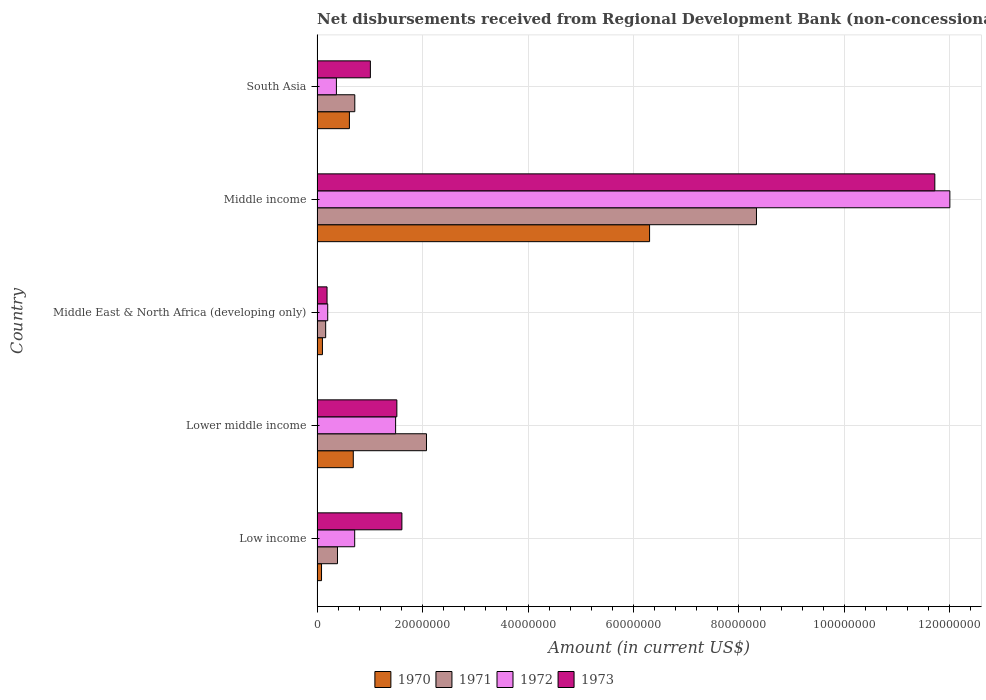How many groups of bars are there?
Ensure brevity in your answer.  5. Are the number of bars per tick equal to the number of legend labels?
Give a very brief answer. Yes. Are the number of bars on each tick of the Y-axis equal?
Make the answer very short. Yes. What is the label of the 4th group of bars from the top?
Offer a very short reply. Lower middle income. What is the amount of disbursements received from Regional Development Bank in 1971 in Middle income?
Your answer should be very brief. 8.33e+07. Across all countries, what is the maximum amount of disbursements received from Regional Development Bank in 1972?
Give a very brief answer. 1.20e+08. Across all countries, what is the minimum amount of disbursements received from Regional Development Bank in 1971?
Provide a short and direct response. 1.64e+06. In which country was the amount of disbursements received from Regional Development Bank in 1971 maximum?
Offer a terse response. Middle income. In which country was the amount of disbursements received from Regional Development Bank in 1971 minimum?
Your answer should be very brief. Middle East & North Africa (developing only). What is the total amount of disbursements received from Regional Development Bank in 1973 in the graph?
Ensure brevity in your answer.  1.60e+08. What is the difference between the amount of disbursements received from Regional Development Bank in 1970 in Middle East & North Africa (developing only) and that in South Asia?
Provide a succinct answer. -5.11e+06. What is the difference between the amount of disbursements received from Regional Development Bank in 1971 in Lower middle income and the amount of disbursements received from Regional Development Bank in 1973 in Middle East & North Africa (developing only)?
Provide a succinct answer. 1.89e+07. What is the average amount of disbursements received from Regional Development Bank in 1971 per country?
Your response must be concise. 2.33e+07. What is the difference between the amount of disbursements received from Regional Development Bank in 1970 and amount of disbursements received from Regional Development Bank in 1972 in Middle income?
Offer a terse response. -5.69e+07. In how many countries, is the amount of disbursements received from Regional Development Bank in 1971 greater than 48000000 US$?
Your answer should be very brief. 1. What is the ratio of the amount of disbursements received from Regional Development Bank in 1970 in Lower middle income to that in South Asia?
Your response must be concise. 1.12. Is the amount of disbursements received from Regional Development Bank in 1971 in Middle East & North Africa (developing only) less than that in Middle income?
Ensure brevity in your answer.  Yes. Is the difference between the amount of disbursements received from Regional Development Bank in 1970 in Middle East & North Africa (developing only) and South Asia greater than the difference between the amount of disbursements received from Regional Development Bank in 1972 in Middle East & North Africa (developing only) and South Asia?
Keep it short and to the point. No. What is the difference between the highest and the second highest amount of disbursements received from Regional Development Bank in 1972?
Offer a very short reply. 1.05e+08. What is the difference between the highest and the lowest amount of disbursements received from Regional Development Bank in 1973?
Your answer should be very brief. 1.15e+08. In how many countries, is the amount of disbursements received from Regional Development Bank in 1973 greater than the average amount of disbursements received from Regional Development Bank in 1973 taken over all countries?
Your response must be concise. 1. Is it the case that in every country, the sum of the amount of disbursements received from Regional Development Bank in 1973 and amount of disbursements received from Regional Development Bank in 1972 is greater than the sum of amount of disbursements received from Regional Development Bank in 1971 and amount of disbursements received from Regional Development Bank in 1970?
Keep it short and to the point. No. What does the 3rd bar from the top in Lower middle income represents?
Provide a succinct answer. 1971. How many bars are there?
Provide a succinct answer. 20. Are all the bars in the graph horizontal?
Offer a terse response. Yes. Does the graph contain any zero values?
Ensure brevity in your answer.  No. Does the graph contain grids?
Your answer should be compact. Yes. Where does the legend appear in the graph?
Give a very brief answer. Bottom center. What is the title of the graph?
Offer a terse response. Net disbursements received from Regional Development Bank (non-concessional). Does "1983" appear as one of the legend labels in the graph?
Keep it short and to the point. No. What is the label or title of the X-axis?
Your answer should be compact. Amount (in current US$). What is the label or title of the Y-axis?
Keep it short and to the point. Country. What is the Amount (in current US$) of 1970 in Low income?
Offer a terse response. 8.50e+05. What is the Amount (in current US$) in 1971 in Low income?
Your response must be concise. 3.88e+06. What is the Amount (in current US$) in 1972 in Low income?
Your answer should be compact. 7.14e+06. What is the Amount (in current US$) of 1973 in Low income?
Offer a very short reply. 1.61e+07. What is the Amount (in current US$) in 1970 in Lower middle income?
Your answer should be compact. 6.87e+06. What is the Amount (in current US$) in 1971 in Lower middle income?
Keep it short and to the point. 2.08e+07. What is the Amount (in current US$) in 1972 in Lower middle income?
Provide a succinct answer. 1.49e+07. What is the Amount (in current US$) of 1973 in Lower middle income?
Give a very brief answer. 1.51e+07. What is the Amount (in current US$) in 1970 in Middle East & North Africa (developing only)?
Give a very brief answer. 1.02e+06. What is the Amount (in current US$) of 1971 in Middle East & North Africa (developing only)?
Your answer should be very brief. 1.64e+06. What is the Amount (in current US$) of 1972 in Middle East & North Africa (developing only)?
Ensure brevity in your answer.  2.02e+06. What is the Amount (in current US$) in 1973 in Middle East & North Africa (developing only)?
Give a very brief answer. 1.90e+06. What is the Amount (in current US$) of 1970 in Middle income?
Your response must be concise. 6.31e+07. What is the Amount (in current US$) of 1971 in Middle income?
Offer a very short reply. 8.33e+07. What is the Amount (in current US$) of 1972 in Middle income?
Make the answer very short. 1.20e+08. What is the Amount (in current US$) of 1973 in Middle income?
Your answer should be compact. 1.17e+08. What is the Amount (in current US$) in 1970 in South Asia?
Ensure brevity in your answer.  6.13e+06. What is the Amount (in current US$) in 1971 in South Asia?
Your answer should be very brief. 7.16e+06. What is the Amount (in current US$) of 1972 in South Asia?
Provide a short and direct response. 3.67e+06. What is the Amount (in current US$) of 1973 in South Asia?
Your response must be concise. 1.01e+07. Across all countries, what is the maximum Amount (in current US$) in 1970?
Keep it short and to the point. 6.31e+07. Across all countries, what is the maximum Amount (in current US$) in 1971?
Provide a succinct answer. 8.33e+07. Across all countries, what is the maximum Amount (in current US$) of 1972?
Your response must be concise. 1.20e+08. Across all countries, what is the maximum Amount (in current US$) in 1973?
Make the answer very short. 1.17e+08. Across all countries, what is the minimum Amount (in current US$) of 1970?
Provide a short and direct response. 8.50e+05. Across all countries, what is the minimum Amount (in current US$) of 1971?
Offer a terse response. 1.64e+06. Across all countries, what is the minimum Amount (in current US$) of 1972?
Provide a short and direct response. 2.02e+06. Across all countries, what is the minimum Amount (in current US$) in 1973?
Your answer should be compact. 1.90e+06. What is the total Amount (in current US$) in 1970 in the graph?
Your answer should be compact. 7.79e+07. What is the total Amount (in current US$) of 1971 in the graph?
Give a very brief answer. 1.17e+08. What is the total Amount (in current US$) in 1972 in the graph?
Offer a very short reply. 1.48e+08. What is the total Amount (in current US$) in 1973 in the graph?
Ensure brevity in your answer.  1.60e+08. What is the difference between the Amount (in current US$) of 1970 in Low income and that in Lower middle income?
Ensure brevity in your answer.  -6.02e+06. What is the difference between the Amount (in current US$) of 1971 in Low income and that in Lower middle income?
Your answer should be compact. -1.69e+07. What is the difference between the Amount (in current US$) in 1972 in Low income and that in Lower middle income?
Give a very brief answer. -7.76e+06. What is the difference between the Amount (in current US$) of 1973 in Low income and that in Lower middle income?
Give a very brief answer. 9.55e+05. What is the difference between the Amount (in current US$) in 1970 in Low income and that in Middle East & North Africa (developing only)?
Provide a short and direct response. -1.71e+05. What is the difference between the Amount (in current US$) of 1971 in Low income and that in Middle East & North Africa (developing only)?
Make the answer very short. 2.24e+06. What is the difference between the Amount (in current US$) in 1972 in Low income and that in Middle East & North Africa (developing only)?
Provide a short and direct response. 5.11e+06. What is the difference between the Amount (in current US$) in 1973 in Low income and that in Middle East & North Africa (developing only)?
Offer a very short reply. 1.42e+07. What is the difference between the Amount (in current US$) in 1970 in Low income and that in Middle income?
Make the answer very short. -6.22e+07. What is the difference between the Amount (in current US$) of 1971 in Low income and that in Middle income?
Offer a terse response. -7.94e+07. What is the difference between the Amount (in current US$) of 1972 in Low income and that in Middle income?
Keep it short and to the point. -1.13e+08. What is the difference between the Amount (in current US$) in 1973 in Low income and that in Middle income?
Offer a terse response. -1.01e+08. What is the difference between the Amount (in current US$) in 1970 in Low income and that in South Asia?
Provide a short and direct response. -5.28e+06. What is the difference between the Amount (in current US$) in 1971 in Low income and that in South Asia?
Your answer should be very brief. -3.28e+06. What is the difference between the Amount (in current US$) of 1972 in Low income and that in South Asia?
Make the answer very short. 3.47e+06. What is the difference between the Amount (in current US$) in 1973 in Low income and that in South Asia?
Make the answer very short. 5.98e+06. What is the difference between the Amount (in current US$) in 1970 in Lower middle income and that in Middle East & North Africa (developing only)?
Give a very brief answer. 5.85e+06. What is the difference between the Amount (in current US$) of 1971 in Lower middle income and that in Middle East & North Africa (developing only)?
Provide a succinct answer. 1.91e+07. What is the difference between the Amount (in current US$) in 1972 in Lower middle income and that in Middle East & North Africa (developing only)?
Offer a terse response. 1.29e+07. What is the difference between the Amount (in current US$) of 1973 in Lower middle income and that in Middle East & North Africa (developing only)?
Your response must be concise. 1.32e+07. What is the difference between the Amount (in current US$) of 1970 in Lower middle income and that in Middle income?
Make the answer very short. -5.62e+07. What is the difference between the Amount (in current US$) of 1971 in Lower middle income and that in Middle income?
Keep it short and to the point. -6.26e+07. What is the difference between the Amount (in current US$) in 1972 in Lower middle income and that in Middle income?
Ensure brevity in your answer.  -1.05e+08. What is the difference between the Amount (in current US$) of 1973 in Lower middle income and that in Middle income?
Offer a terse response. -1.02e+08. What is the difference between the Amount (in current US$) of 1970 in Lower middle income and that in South Asia?
Keep it short and to the point. 7.37e+05. What is the difference between the Amount (in current US$) of 1971 in Lower middle income and that in South Asia?
Offer a terse response. 1.36e+07. What is the difference between the Amount (in current US$) in 1972 in Lower middle income and that in South Asia?
Offer a terse response. 1.12e+07. What is the difference between the Amount (in current US$) of 1973 in Lower middle income and that in South Asia?
Offer a very short reply. 5.02e+06. What is the difference between the Amount (in current US$) of 1970 in Middle East & North Africa (developing only) and that in Middle income?
Your answer should be compact. -6.20e+07. What is the difference between the Amount (in current US$) of 1971 in Middle East & North Africa (developing only) and that in Middle income?
Keep it short and to the point. -8.17e+07. What is the difference between the Amount (in current US$) in 1972 in Middle East & North Africa (developing only) and that in Middle income?
Your answer should be very brief. -1.18e+08. What is the difference between the Amount (in current US$) in 1973 in Middle East & North Africa (developing only) and that in Middle income?
Your answer should be compact. -1.15e+08. What is the difference between the Amount (in current US$) of 1970 in Middle East & North Africa (developing only) and that in South Asia?
Keep it short and to the point. -5.11e+06. What is the difference between the Amount (in current US$) in 1971 in Middle East & North Africa (developing only) and that in South Asia?
Offer a very short reply. -5.52e+06. What is the difference between the Amount (in current US$) of 1972 in Middle East & North Africa (developing only) and that in South Asia?
Give a very brief answer. -1.64e+06. What is the difference between the Amount (in current US$) of 1973 in Middle East & North Africa (developing only) and that in South Asia?
Make the answer very short. -8.22e+06. What is the difference between the Amount (in current US$) in 1970 in Middle income and that in South Asia?
Keep it short and to the point. 5.69e+07. What is the difference between the Amount (in current US$) of 1971 in Middle income and that in South Asia?
Provide a short and direct response. 7.62e+07. What is the difference between the Amount (in current US$) of 1972 in Middle income and that in South Asia?
Offer a very short reply. 1.16e+08. What is the difference between the Amount (in current US$) of 1973 in Middle income and that in South Asia?
Provide a short and direct response. 1.07e+08. What is the difference between the Amount (in current US$) in 1970 in Low income and the Amount (in current US$) in 1971 in Lower middle income?
Your answer should be compact. -1.99e+07. What is the difference between the Amount (in current US$) of 1970 in Low income and the Amount (in current US$) of 1972 in Lower middle income?
Offer a terse response. -1.40e+07. What is the difference between the Amount (in current US$) of 1970 in Low income and the Amount (in current US$) of 1973 in Lower middle income?
Make the answer very short. -1.43e+07. What is the difference between the Amount (in current US$) in 1971 in Low income and the Amount (in current US$) in 1972 in Lower middle income?
Make the answer very short. -1.10e+07. What is the difference between the Amount (in current US$) of 1971 in Low income and the Amount (in current US$) of 1973 in Lower middle income?
Offer a terse response. -1.13e+07. What is the difference between the Amount (in current US$) in 1972 in Low income and the Amount (in current US$) in 1973 in Lower middle income?
Offer a terse response. -8.00e+06. What is the difference between the Amount (in current US$) in 1970 in Low income and the Amount (in current US$) in 1971 in Middle East & North Africa (developing only)?
Your answer should be very brief. -7.85e+05. What is the difference between the Amount (in current US$) in 1970 in Low income and the Amount (in current US$) in 1972 in Middle East & North Africa (developing only)?
Provide a short and direct response. -1.17e+06. What is the difference between the Amount (in current US$) of 1970 in Low income and the Amount (in current US$) of 1973 in Middle East & North Africa (developing only)?
Your answer should be compact. -1.05e+06. What is the difference between the Amount (in current US$) in 1971 in Low income and the Amount (in current US$) in 1972 in Middle East & North Africa (developing only)?
Offer a very short reply. 1.85e+06. What is the difference between the Amount (in current US$) of 1971 in Low income and the Amount (in current US$) of 1973 in Middle East & North Africa (developing only)?
Make the answer very short. 1.98e+06. What is the difference between the Amount (in current US$) of 1972 in Low income and the Amount (in current US$) of 1973 in Middle East & North Africa (developing only)?
Offer a very short reply. 5.24e+06. What is the difference between the Amount (in current US$) in 1970 in Low income and the Amount (in current US$) in 1971 in Middle income?
Give a very brief answer. -8.25e+07. What is the difference between the Amount (in current US$) of 1970 in Low income and the Amount (in current US$) of 1972 in Middle income?
Give a very brief answer. -1.19e+08. What is the difference between the Amount (in current US$) of 1970 in Low income and the Amount (in current US$) of 1973 in Middle income?
Offer a terse response. -1.16e+08. What is the difference between the Amount (in current US$) in 1971 in Low income and the Amount (in current US$) in 1972 in Middle income?
Give a very brief answer. -1.16e+08. What is the difference between the Amount (in current US$) in 1971 in Low income and the Amount (in current US$) in 1973 in Middle income?
Keep it short and to the point. -1.13e+08. What is the difference between the Amount (in current US$) of 1972 in Low income and the Amount (in current US$) of 1973 in Middle income?
Provide a short and direct response. -1.10e+08. What is the difference between the Amount (in current US$) in 1970 in Low income and the Amount (in current US$) in 1971 in South Asia?
Your response must be concise. -6.31e+06. What is the difference between the Amount (in current US$) of 1970 in Low income and the Amount (in current US$) of 1972 in South Asia?
Give a very brief answer. -2.82e+06. What is the difference between the Amount (in current US$) in 1970 in Low income and the Amount (in current US$) in 1973 in South Asia?
Offer a very short reply. -9.26e+06. What is the difference between the Amount (in current US$) of 1971 in Low income and the Amount (in current US$) of 1972 in South Asia?
Provide a short and direct response. 2.06e+05. What is the difference between the Amount (in current US$) in 1971 in Low income and the Amount (in current US$) in 1973 in South Asia?
Give a very brief answer. -6.24e+06. What is the difference between the Amount (in current US$) in 1972 in Low income and the Amount (in current US$) in 1973 in South Asia?
Keep it short and to the point. -2.98e+06. What is the difference between the Amount (in current US$) of 1970 in Lower middle income and the Amount (in current US$) of 1971 in Middle East & North Africa (developing only)?
Make the answer very short. 5.24e+06. What is the difference between the Amount (in current US$) in 1970 in Lower middle income and the Amount (in current US$) in 1972 in Middle East & North Africa (developing only)?
Offer a terse response. 4.85e+06. What is the difference between the Amount (in current US$) of 1970 in Lower middle income and the Amount (in current US$) of 1973 in Middle East & North Africa (developing only)?
Offer a terse response. 4.98e+06. What is the difference between the Amount (in current US$) of 1971 in Lower middle income and the Amount (in current US$) of 1972 in Middle East & North Africa (developing only)?
Provide a short and direct response. 1.87e+07. What is the difference between the Amount (in current US$) in 1971 in Lower middle income and the Amount (in current US$) in 1973 in Middle East & North Africa (developing only)?
Provide a short and direct response. 1.89e+07. What is the difference between the Amount (in current US$) of 1972 in Lower middle income and the Amount (in current US$) of 1973 in Middle East & North Africa (developing only)?
Make the answer very short. 1.30e+07. What is the difference between the Amount (in current US$) of 1970 in Lower middle income and the Amount (in current US$) of 1971 in Middle income?
Your answer should be compact. -7.65e+07. What is the difference between the Amount (in current US$) in 1970 in Lower middle income and the Amount (in current US$) in 1972 in Middle income?
Offer a very short reply. -1.13e+08. What is the difference between the Amount (in current US$) of 1970 in Lower middle income and the Amount (in current US$) of 1973 in Middle income?
Offer a very short reply. -1.10e+08. What is the difference between the Amount (in current US$) in 1971 in Lower middle income and the Amount (in current US$) in 1972 in Middle income?
Provide a short and direct response. -9.92e+07. What is the difference between the Amount (in current US$) of 1971 in Lower middle income and the Amount (in current US$) of 1973 in Middle income?
Provide a short and direct response. -9.64e+07. What is the difference between the Amount (in current US$) in 1972 in Lower middle income and the Amount (in current US$) in 1973 in Middle income?
Provide a succinct answer. -1.02e+08. What is the difference between the Amount (in current US$) of 1970 in Lower middle income and the Amount (in current US$) of 1971 in South Asia?
Your answer should be compact. -2.87e+05. What is the difference between the Amount (in current US$) in 1970 in Lower middle income and the Amount (in current US$) in 1972 in South Asia?
Offer a terse response. 3.20e+06. What is the difference between the Amount (in current US$) of 1970 in Lower middle income and the Amount (in current US$) of 1973 in South Asia?
Make the answer very short. -3.24e+06. What is the difference between the Amount (in current US$) in 1971 in Lower middle income and the Amount (in current US$) in 1972 in South Asia?
Offer a terse response. 1.71e+07. What is the difference between the Amount (in current US$) of 1971 in Lower middle income and the Amount (in current US$) of 1973 in South Asia?
Keep it short and to the point. 1.06e+07. What is the difference between the Amount (in current US$) of 1972 in Lower middle income and the Amount (in current US$) of 1973 in South Asia?
Offer a very short reply. 4.78e+06. What is the difference between the Amount (in current US$) of 1970 in Middle East & North Africa (developing only) and the Amount (in current US$) of 1971 in Middle income?
Give a very brief answer. -8.23e+07. What is the difference between the Amount (in current US$) of 1970 in Middle East & North Africa (developing only) and the Amount (in current US$) of 1972 in Middle income?
Your answer should be very brief. -1.19e+08. What is the difference between the Amount (in current US$) of 1970 in Middle East & North Africa (developing only) and the Amount (in current US$) of 1973 in Middle income?
Give a very brief answer. -1.16e+08. What is the difference between the Amount (in current US$) of 1971 in Middle East & North Africa (developing only) and the Amount (in current US$) of 1972 in Middle income?
Offer a very short reply. -1.18e+08. What is the difference between the Amount (in current US$) of 1971 in Middle East & North Africa (developing only) and the Amount (in current US$) of 1973 in Middle income?
Keep it short and to the point. -1.16e+08. What is the difference between the Amount (in current US$) in 1972 in Middle East & North Africa (developing only) and the Amount (in current US$) in 1973 in Middle income?
Offer a terse response. -1.15e+08. What is the difference between the Amount (in current US$) of 1970 in Middle East & North Africa (developing only) and the Amount (in current US$) of 1971 in South Asia?
Ensure brevity in your answer.  -6.14e+06. What is the difference between the Amount (in current US$) of 1970 in Middle East & North Africa (developing only) and the Amount (in current US$) of 1972 in South Asia?
Make the answer very short. -2.65e+06. What is the difference between the Amount (in current US$) in 1970 in Middle East & North Africa (developing only) and the Amount (in current US$) in 1973 in South Asia?
Ensure brevity in your answer.  -9.09e+06. What is the difference between the Amount (in current US$) of 1971 in Middle East & North Africa (developing only) and the Amount (in current US$) of 1972 in South Asia?
Keep it short and to the point. -2.03e+06. What is the difference between the Amount (in current US$) of 1971 in Middle East & North Africa (developing only) and the Amount (in current US$) of 1973 in South Asia?
Your answer should be compact. -8.48e+06. What is the difference between the Amount (in current US$) in 1972 in Middle East & North Africa (developing only) and the Amount (in current US$) in 1973 in South Asia?
Keep it short and to the point. -8.09e+06. What is the difference between the Amount (in current US$) in 1970 in Middle income and the Amount (in current US$) in 1971 in South Asia?
Provide a short and direct response. 5.59e+07. What is the difference between the Amount (in current US$) of 1970 in Middle income and the Amount (in current US$) of 1972 in South Asia?
Provide a succinct answer. 5.94e+07. What is the difference between the Amount (in current US$) of 1970 in Middle income and the Amount (in current US$) of 1973 in South Asia?
Offer a very short reply. 5.29e+07. What is the difference between the Amount (in current US$) in 1971 in Middle income and the Amount (in current US$) in 1972 in South Asia?
Provide a short and direct response. 7.97e+07. What is the difference between the Amount (in current US$) in 1971 in Middle income and the Amount (in current US$) in 1973 in South Asia?
Offer a very short reply. 7.32e+07. What is the difference between the Amount (in current US$) in 1972 in Middle income and the Amount (in current US$) in 1973 in South Asia?
Provide a short and direct response. 1.10e+08. What is the average Amount (in current US$) in 1970 per country?
Ensure brevity in your answer.  1.56e+07. What is the average Amount (in current US$) of 1971 per country?
Your response must be concise. 2.33e+07. What is the average Amount (in current US$) of 1972 per country?
Offer a terse response. 2.95e+07. What is the average Amount (in current US$) in 1973 per country?
Ensure brevity in your answer.  3.21e+07. What is the difference between the Amount (in current US$) of 1970 and Amount (in current US$) of 1971 in Low income?
Provide a short and direct response. -3.02e+06. What is the difference between the Amount (in current US$) in 1970 and Amount (in current US$) in 1972 in Low income?
Give a very brief answer. -6.29e+06. What is the difference between the Amount (in current US$) of 1970 and Amount (in current US$) of 1973 in Low income?
Provide a succinct answer. -1.52e+07. What is the difference between the Amount (in current US$) of 1971 and Amount (in current US$) of 1972 in Low income?
Offer a very short reply. -3.26e+06. What is the difference between the Amount (in current US$) of 1971 and Amount (in current US$) of 1973 in Low income?
Ensure brevity in your answer.  -1.22e+07. What is the difference between the Amount (in current US$) in 1972 and Amount (in current US$) in 1973 in Low income?
Offer a terse response. -8.95e+06. What is the difference between the Amount (in current US$) in 1970 and Amount (in current US$) in 1971 in Lower middle income?
Provide a short and direct response. -1.39e+07. What is the difference between the Amount (in current US$) in 1970 and Amount (in current US$) in 1972 in Lower middle income?
Your answer should be compact. -8.03e+06. What is the difference between the Amount (in current US$) of 1970 and Amount (in current US$) of 1973 in Lower middle income?
Your response must be concise. -8.26e+06. What is the difference between the Amount (in current US$) of 1971 and Amount (in current US$) of 1972 in Lower middle income?
Offer a very short reply. 5.85e+06. What is the difference between the Amount (in current US$) of 1971 and Amount (in current US$) of 1973 in Lower middle income?
Keep it short and to the point. 5.62e+06. What is the difference between the Amount (in current US$) in 1972 and Amount (in current US$) in 1973 in Lower middle income?
Give a very brief answer. -2.36e+05. What is the difference between the Amount (in current US$) in 1970 and Amount (in current US$) in 1971 in Middle East & North Africa (developing only)?
Your response must be concise. -6.14e+05. What is the difference between the Amount (in current US$) in 1970 and Amount (in current US$) in 1972 in Middle East & North Africa (developing only)?
Your answer should be very brief. -1.00e+06. What is the difference between the Amount (in current US$) of 1970 and Amount (in current US$) of 1973 in Middle East & North Africa (developing only)?
Your response must be concise. -8.75e+05. What is the difference between the Amount (in current US$) in 1971 and Amount (in current US$) in 1972 in Middle East & North Africa (developing only)?
Your answer should be compact. -3.89e+05. What is the difference between the Amount (in current US$) of 1971 and Amount (in current US$) of 1973 in Middle East & North Africa (developing only)?
Provide a succinct answer. -2.61e+05. What is the difference between the Amount (in current US$) in 1972 and Amount (in current US$) in 1973 in Middle East & North Africa (developing only)?
Make the answer very short. 1.28e+05. What is the difference between the Amount (in current US$) of 1970 and Amount (in current US$) of 1971 in Middle income?
Make the answer very short. -2.03e+07. What is the difference between the Amount (in current US$) in 1970 and Amount (in current US$) in 1972 in Middle income?
Offer a very short reply. -5.69e+07. What is the difference between the Amount (in current US$) of 1970 and Amount (in current US$) of 1973 in Middle income?
Keep it short and to the point. -5.41e+07. What is the difference between the Amount (in current US$) of 1971 and Amount (in current US$) of 1972 in Middle income?
Make the answer very short. -3.67e+07. What is the difference between the Amount (in current US$) of 1971 and Amount (in current US$) of 1973 in Middle income?
Make the answer very short. -3.38e+07. What is the difference between the Amount (in current US$) of 1972 and Amount (in current US$) of 1973 in Middle income?
Your answer should be very brief. 2.85e+06. What is the difference between the Amount (in current US$) in 1970 and Amount (in current US$) in 1971 in South Asia?
Provide a succinct answer. -1.02e+06. What is the difference between the Amount (in current US$) of 1970 and Amount (in current US$) of 1972 in South Asia?
Your answer should be compact. 2.46e+06. What is the difference between the Amount (in current US$) of 1970 and Amount (in current US$) of 1973 in South Asia?
Your answer should be compact. -3.98e+06. What is the difference between the Amount (in current US$) in 1971 and Amount (in current US$) in 1972 in South Asia?
Offer a very short reply. 3.49e+06. What is the difference between the Amount (in current US$) of 1971 and Amount (in current US$) of 1973 in South Asia?
Your response must be concise. -2.95e+06. What is the difference between the Amount (in current US$) of 1972 and Amount (in current US$) of 1973 in South Asia?
Keep it short and to the point. -6.44e+06. What is the ratio of the Amount (in current US$) in 1970 in Low income to that in Lower middle income?
Your response must be concise. 0.12. What is the ratio of the Amount (in current US$) in 1971 in Low income to that in Lower middle income?
Ensure brevity in your answer.  0.19. What is the ratio of the Amount (in current US$) of 1972 in Low income to that in Lower middle income?
Offer a terse response. 0.48. What is the ratio of the Amount (in current US$) of 1973 in Low income to that in Lower middle income?
Provide a succinct answer. 1.06. What is the ratio of the Amount (in current US$) in 1970 in Low income to that in Middle East & North Africa (developing only)?
Your response must be concise. 0.83. What is the ratio of the Amount (in current US$) of 1971 in Low income to that in Middle East & North Africa (developing only)?
Your answer should be very brief. 2.37. What is the ratio of the Amount (in current US$) of 1972 in Low income to that in Middle East & North Africa (developing only)?
Make the answer very short. 3.53. What is the ratio of the Amount (in current US$) in 1973 in Low income to that in Middle East & North Africa (developing only)?
Ensure brevity in your answer.  8.49. What is the ratio of the Amount (in current US$) of 1970 in Low income to that in Middle income?
Keep it short and to the point. 0.01. What is the ratio of the Amount (in current US$) in 1971 in Low income to that in Middle income?
Offer a terse response. 0.05. What is the ratio of the Amount (in current US$) of 1972 in Low income to that in Middle income?
Make the answer very short. 0.06. What is the ratio of the Amount (in current US$) in 1973 in Low income to that in Middle income?
Your answer should be compact. 0.14. What is the ratio of the Amount (in current US$) of 1970 in Low income to that in South Asia?
Make the answer very short. 0.14. What is the ratio of the Amount (in current US$) of 1971 in Low income to that in South Asia?
Give a very brief answer. 0.54. What is the ratio of the Amount (in current US$) in 1972 in Low income to that in South Asia?
Your answer should be compact. 1.95. What is the ratio of the Amount (in current US$) of 1973 in Low income to that in South Asia?
Give a very brief answer. 1.59. What is the ratio of the Amount (in current US$) in 1970 in Lower middle income to that in Middle East & North Africa (developing only)?
Offer a very short reply. 6.73. What is the ratio of the Amount (in current US$) in 1971 in Lower middle income to that in Middle East & North Africa (developing only)?
Your answer should be very brief. 12.69. What is the ratio of the Amount (in current US$) of 1972 in Lower middle income to that in Middle East & North Africa (developing only)?
Your answer should be very brief. 7.36. What is the ratio of the Amount (in current US$) in 1973 in Lower middle income to that in Middle East & North Africa (developing only)?
Provide a succinct answer. 7.98. What is the ratio of the Amount (in current US$) of 1970 in Lower middle income to that in Middle income?
Ensure brevity in your answer.  0.11. What is the ratio of the Amount (in current US$) of 1971 in Lower middle income to that in Middle income?
Your answer should be compact. 0.25. What is the ratio of the Amount (in current US$) in 1972 in Lower middle income to that in Middle income?
Your answer should be very brief. 0.12. What is the ratio of the Amount (in current US$) in 1973 in Lower middle income to that in Middle income?
Provide a succinct answer. 0.13. What is the ratio of the Amount (in current US$) in 1970 in Lower middle income to that in South Asia?
Provide a succinct answer. 1.12. What is the ratio of the Amount (in current US$) of 1971 in Lower middle income to that in South Asia?
Your answer should be very brief. 2.9. What is the ratio of the Amount (in current US$) of 1972 in Lower middle income to that in South Asia?
Your response must be concise. 4.06. What is the ratio of the Amount (in current US$) of 1973 in Lower middle income to that in South Asia?
Offer a terse response. 1.5. What is the ratio of the Amount (in current US$) of 1970 in Middle East & North Africa (developing only) to that in Middle income?
Ensure brevity in your answer.  0.02. What is the ratio of the Amount (in current US$) in 1971 in Middle East & North Africa (developing only) to that in Middle income?
Your response must be concise. 0.02. What is the ratio of the Amount (in current US$) of 1972 in Middle East & North Africa (developing only) to that in Middle income?
Your answer should be very brief. 0.02. What is the ratio of the Amount (in current US$) in 1973 in Middle East & North Africa (developing only) to that in Middle income?
Make the answer very short. 0.02. What is the ratio of the Amount (in current US$) in 1970 in Middle East & North Africa (developing only) to that in South Asia?
Ensure brevity in your answer.  0.17. What is the ratio of the Amount (in current US$) of 1971 in Middle East & North Africa (developing only) to that in South Asia?
Your answer should be compact. 0.23. What is the ratio of the Amount (in current US$) of 1972 in Middle East & North Africa (developing only) to that in South Asia?
Keep it short and to the point. 0.55. What is the ratio of the Amount (in current US$) in 1973 in Middle East & North Africa (developing only) to that in South Asia?
Offer a terse response. 0.19. What is the ratio of the Amount (in current US$) in 1970 in Middle income to that in South Asia?
Your answer should be very brief. 10.28. What is the ratio of the Amount (in current US$) of 1971 in Middle income to that in South Asia?
Give a very brief answer. 11.64. What is the ratio of the Amount (in current US$) of 1972 in Middle income to that in South Asia?
Your response must be concise. 32.71. What is the ratio of the Amount (in current US$) in 1973 in Middle income to that in South Asia?
Make the answer very short. 11.58. What is the difference between the highest and the second highest Amount (in current US$) in 1970?
Provide a succinct answer. 5.62e+07. What is the difference between the highest and the second highest Amount (in current US$) in 1971?
Your answer should be compact. 6.26e+07. What is the difference between the highest and the second highest Amount (in current US$) of 1972?
Make the answer very short. 1.05e+08. What is the difference between the highest and the second highest Amount (in current US$) of 1973?
Make the answer very short. 1.01e+08. What is the difference between the highest and the lowest Amount (in current US$) in 1970?
Offer a terse response. 6.22e+07. What is the difference between the highest and the lowest Amount (in current US$) of 1971?
Your answer should be very brief. 8.17e+07. What is the difference between the highest and the lowest Amount (in current US$) in 1972?
Your answer should be very brief. 1.18e+08. What is the difference between the highest and the lowest Amount (in current US$) in 1973?
Offer a very short reply. 1.15e+08. 